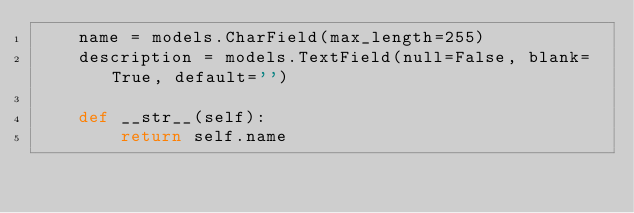Convert code to text. <code><loc_0><loc_0><loc_500><loc_500><_Python_>    name = models.CharField(max_length=255)
    description = models.TextField(null=False, blank=True, default='')

    def __str__(self):
        return self.name
</code> 